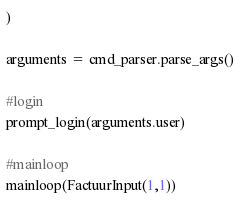Convert code to text. <code><loc_0><loc_0><loc_500><loc_500><_Python_>)

arguments = cmd_parser.parse_args()

#login
prompt_login(arguments.user)

#mainloop
mainloop(FactuurInput(1,1))
</code> 